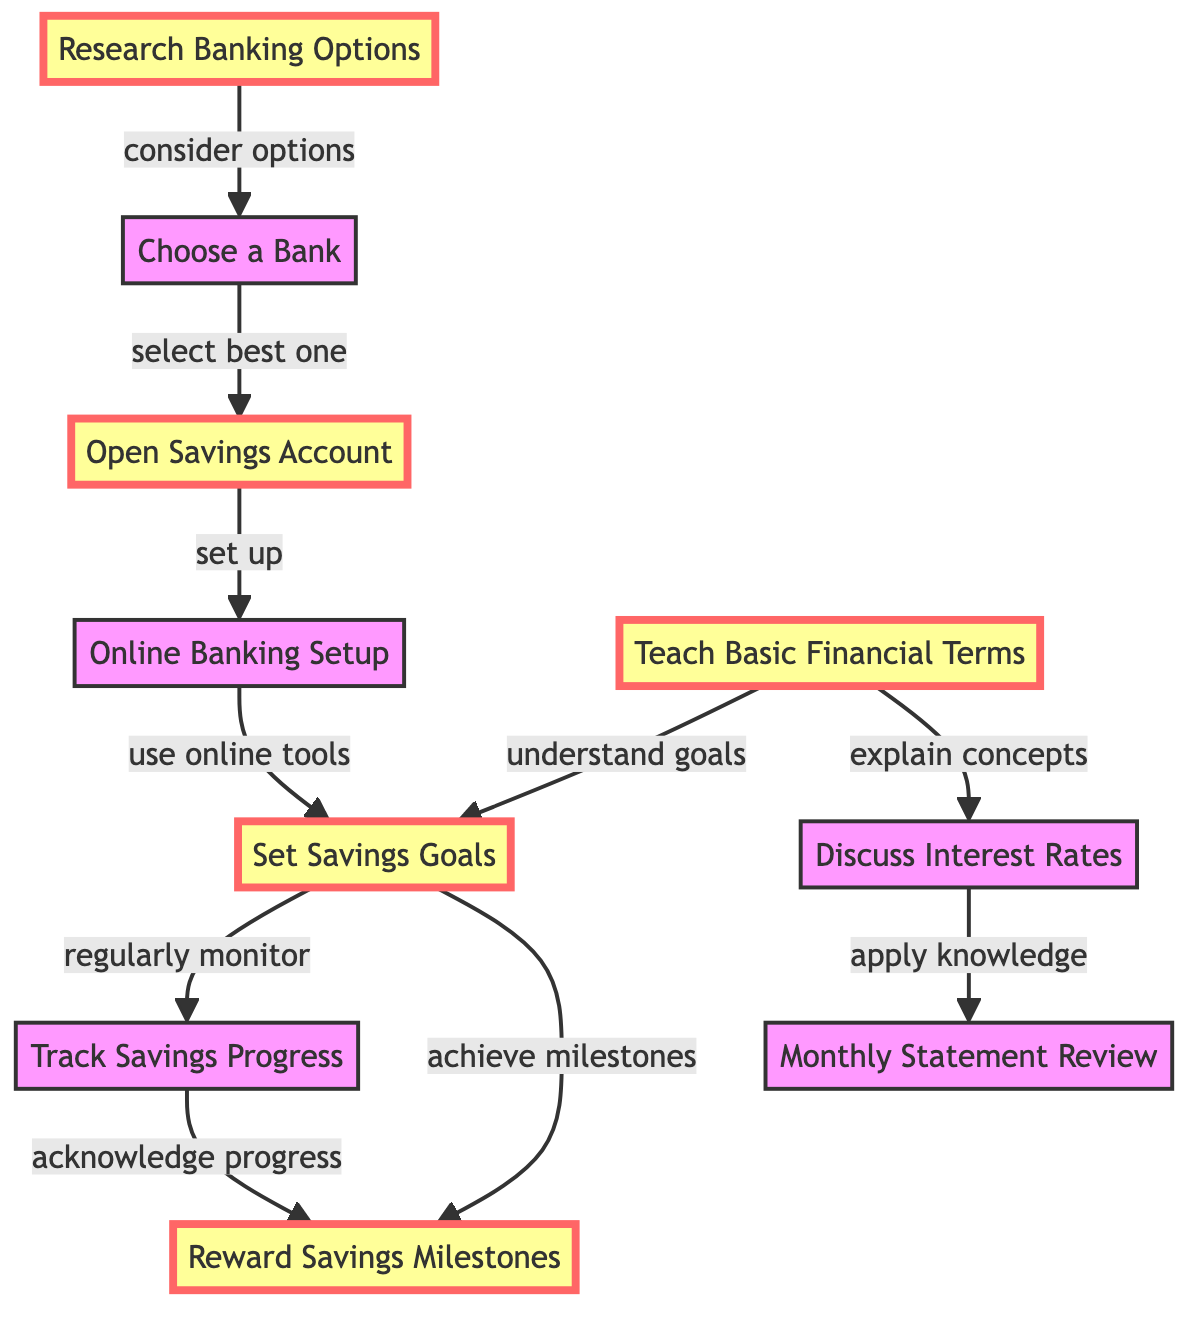What is the first step in setting up a kid's savings account? According to the diagram, the first step (node 1) is "Research Banking Options". This is the entry point in the flow and indicates the initial action to take before any other tasks.
Answer: Research Banking Options How many nodes are present in the diagram? The diagram has 10 nodes total, each representing a different action or concept related to managing a kid's savings account. Counting all the unique actions leads to this number.
Answer: 10 What action follows after choosing a bank? The action that follows after "Choose a Bank" (node 2) is "Open Savings Account" (node 3). The diagram shows a direct edge from node 2 to node 3 indicating the sequence of steps.
Answer: Open Savings Account Which two nodes are connected by the relationship "acknowledge progress"? The nodes connected by the relationship "acknowledge progress" are "Track Savings Progress" (node 7) and "Reward Savings Milestones" (node 9). The edge between these nodes clearly indicates this relationship in the diagram.
Answer: Track Savings Progress and Reward Savings Milestones How many edges are there leading to "Set Savings Goals"? There are 2 edges leading to "Set Savings Goals" (node 6): one from "Online Banking Setup" (node 4) and another from "Teach Basic Financial Terms" (node 5). This can be confirmed by examining the respective relationships within the diagram.
Answer: 2 Which node is the final action after discussing interest rates? The final action after "Discuss Interest Rates" (node 8) is "Monthly Statement Review" (node 10). The diagram clearly shows a directed edge from node 8 to node 10, indicating this sequential relationship.
Answer: Monthly Statement Review What nodes lead directly to "Track Savings Progress"? The node "Set Savings Goals" (node 6) is the only one leading directly to "Track Savings Progress" (node 7), as shown in the diagram where there is a directed edge from node 6 to node 7.
Answer: Set Savings Goals What relationship comes after "Teach Basic Financial Terms"? The relationship that comes after "Teach Basic Financial Terms" (node 5) is "understand goals", leading to "Set Savings Goals" (node 6). This is evident from the directed edge between these two nodes.
Answer: understand goals Which nodes are involved in achieving savings milestones? The nodes involved in achieving savings milestones are "Set Savings Goals" (node 6) and "Reward Savings Milestones" (node 9). The diagram shows a direct edge from node 6 to node 9, which indicates the relationship between setting goals and achieving rewards.
Answer: Set Savings Goals and Reward Savings Milestones 